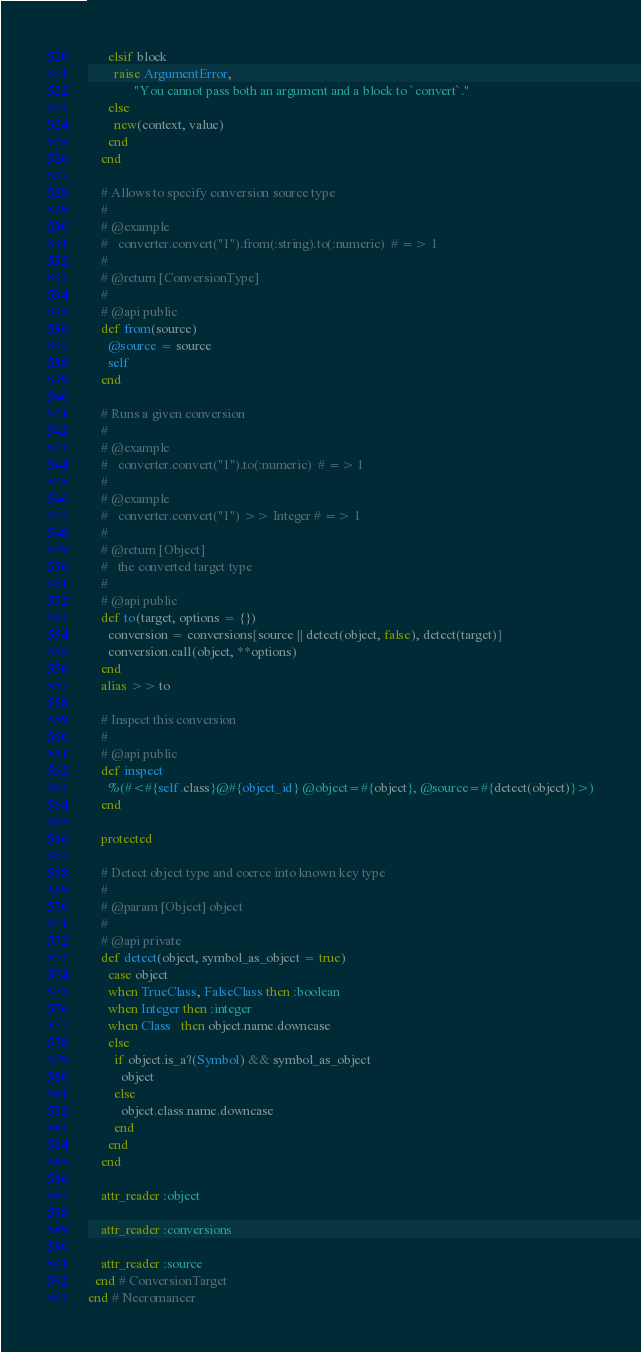Convert code to text. <code><loc_0><loc_0><loc_500><loc_500><_Ruby_>      elsif block
        raise ArgumentError,
              "You cannot pass both an argument and a block to `convert`."
      else
        new(context, value)
      end
    end

    # Allows to specify conversion source type
    #
    # @example
    #   converter.convert("1").from(:string).to(:numeric)  # => 1
    #
    # @return [ConversionType]
    #
    # @api public
    def from(source)
      @source = source
      self
    end

    # Runs a given conversion
    #
    # @example
    #   converter.convert("1").to(:numeric)  # => 1
    #
    # @example
    #   converter.convert("1") >> Integer # => 1
    #
    # @return [Object]
    #   the converted target type
    #
    # @api public
    def to(target, options = {})
      conversion = conversions[source || detect(object, false), detect(target)]
      conversion.call(object, **options)
    end
    alias >> to

    # Inspect this conversion
    #
    # @api public
    def inspect
      %(#<#{self.class}@#{object_id} @object=#{object}, @source=#{detect(object)}>)
    end

    protected

    # Detect object type and coerce into known key type
    #
    # @param [Object] object
    #
    # @api private
    def detect(object, symbol_as_object = true)
      case object
      when TrueClass, FalseClass then :boolean
      when Integer then :integer
      when Class   then object.name.downcase
      else
        if object.is_a?(Symbol) && symbol_as_object
          object
        else
          object.class.name.downcase
        end
      end
    end

    attr_reader :object

    attr_reader :conversions

    attr_reader :source
  end # ConversionTarget
end # Necromancer
</code> 